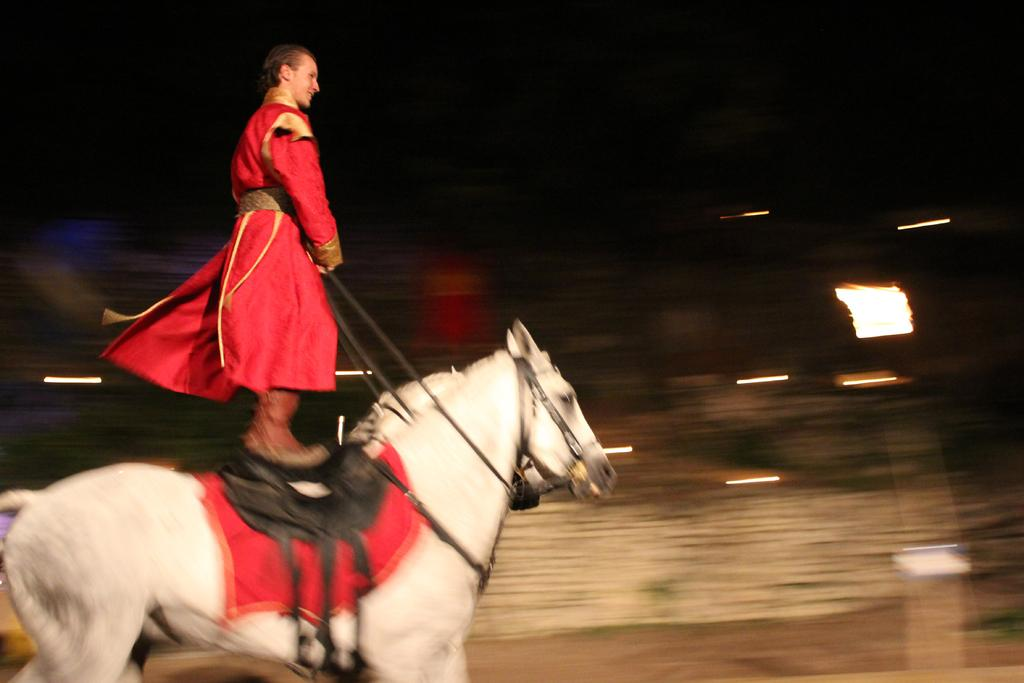What is the main subject of the image? There is a man in the image. What is the man doing in the image? The man is standing on a horse and riding it. What can be seen in the background of the image? There are lights visible in the background of the image. What type of jellyfish can be seen swimming in the background of the image? There are no jellyfish present in the image; it features a man riding a horse with lights in the background. 